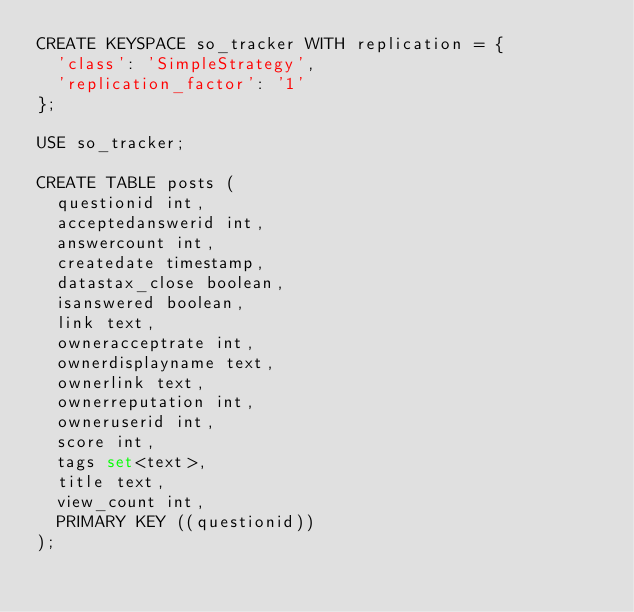<code> <loc_0><loc_0><loc_500><loc_500><_SQL_>CREATE KEYSPACE so_tracker WITH replication = {
  'class': 'SimpleStrategy',
  'replication_factor': '1'
};

USE so_tracker;

CREATE TABLE posts (
  questionid int,
  acceptedanswerid int,
  answercount int,
  createdate timestamp,
  datastax_close boolean,
  isanswered boolean,
  link text,
  owneracceptrate int,
  ownerdisplayname text,
  ownerlink text,
  ownerreputation int,
  owneruserid int,
  score int,
  tags set<text>,
  title text,
  view_count int,
  PRIMARY KEY ((questionid))
);
</code> 